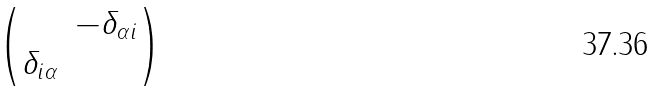<formula> <loc_0><loc_0><loc_500><loc_500>\begin{pmatrix} & - \delta _ { \alpha i } \\ \delta _ { i \alpha } & \end{pmatrix}</formula> 